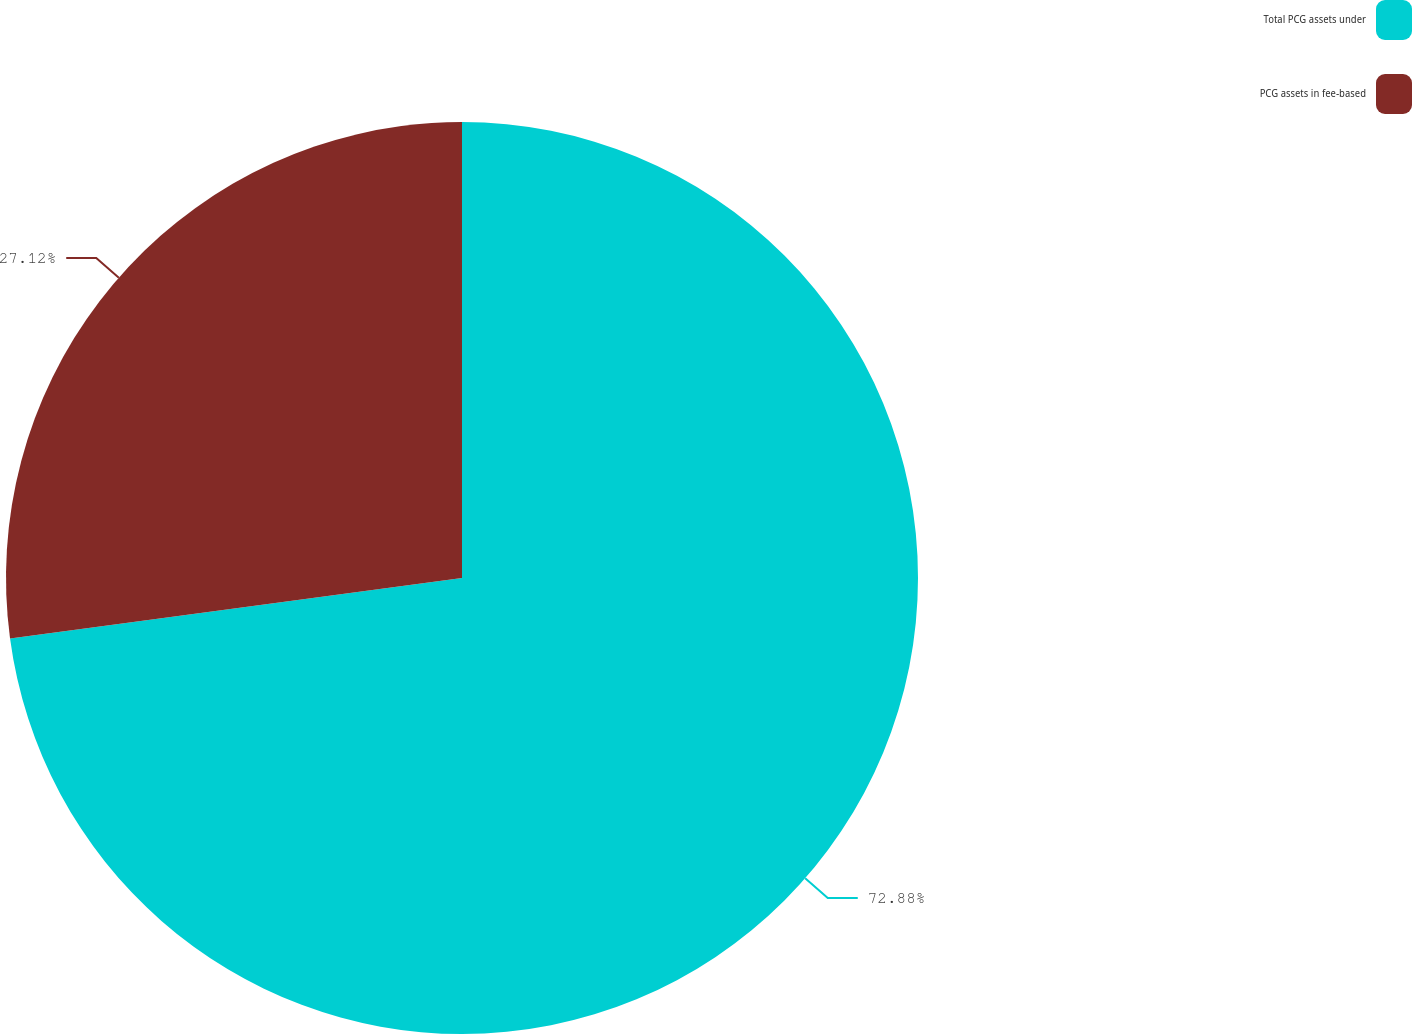<chart> <loc_0><loc_0><loc_500><loc_500><pie_chart><fcel>Total PCG assets under<fcel>PCG assets in fee-based<nl><fcel>72.88%<fcel>27.12%<nl></chart> 